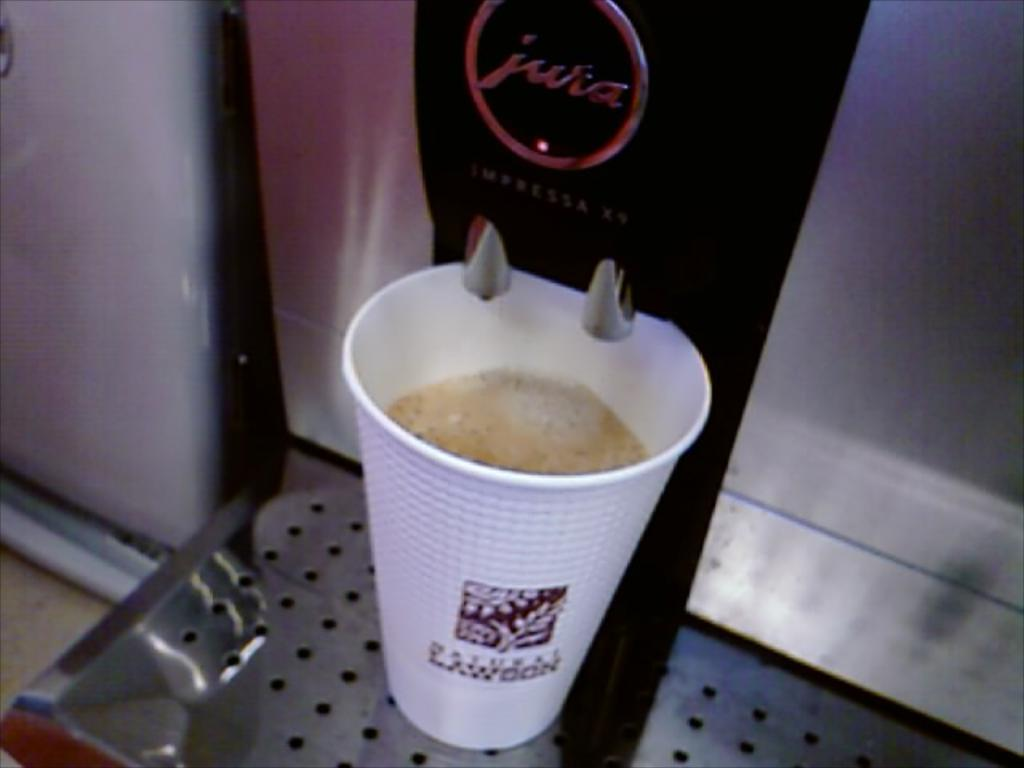What is in the glass that is visible in the image? There is coffee in the glass in the image. Where is the glass placed in the image? The glass is placed on a coffee machine rack. What type of surface is visible in the image? The image shows a floor. What type of mountain can be seen in the background of the image? There is no mountain visible in the image; it only shows a glass of coffee, a coffee machine rack, and a floor. 